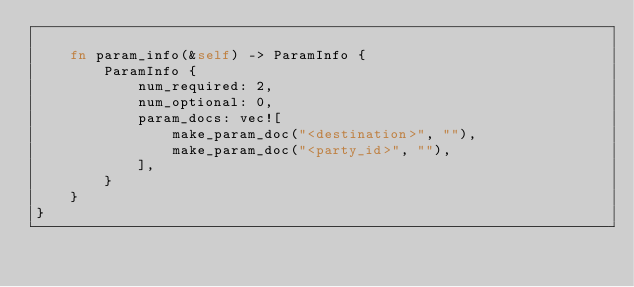Convert code to text. <code><loc_0><loc_0><loc_500><loc_500><_Rust_>
    fn param_info(&self) -> ParamInfo {
        ParamInfo {
            num_required: 2,
            num_optional: 0,
            param_docs: vec![
                make_param_doc("<destination>", ""),
                make_param_doc("<party_id>", ""),
            ],
        }
    }
}
</code> 